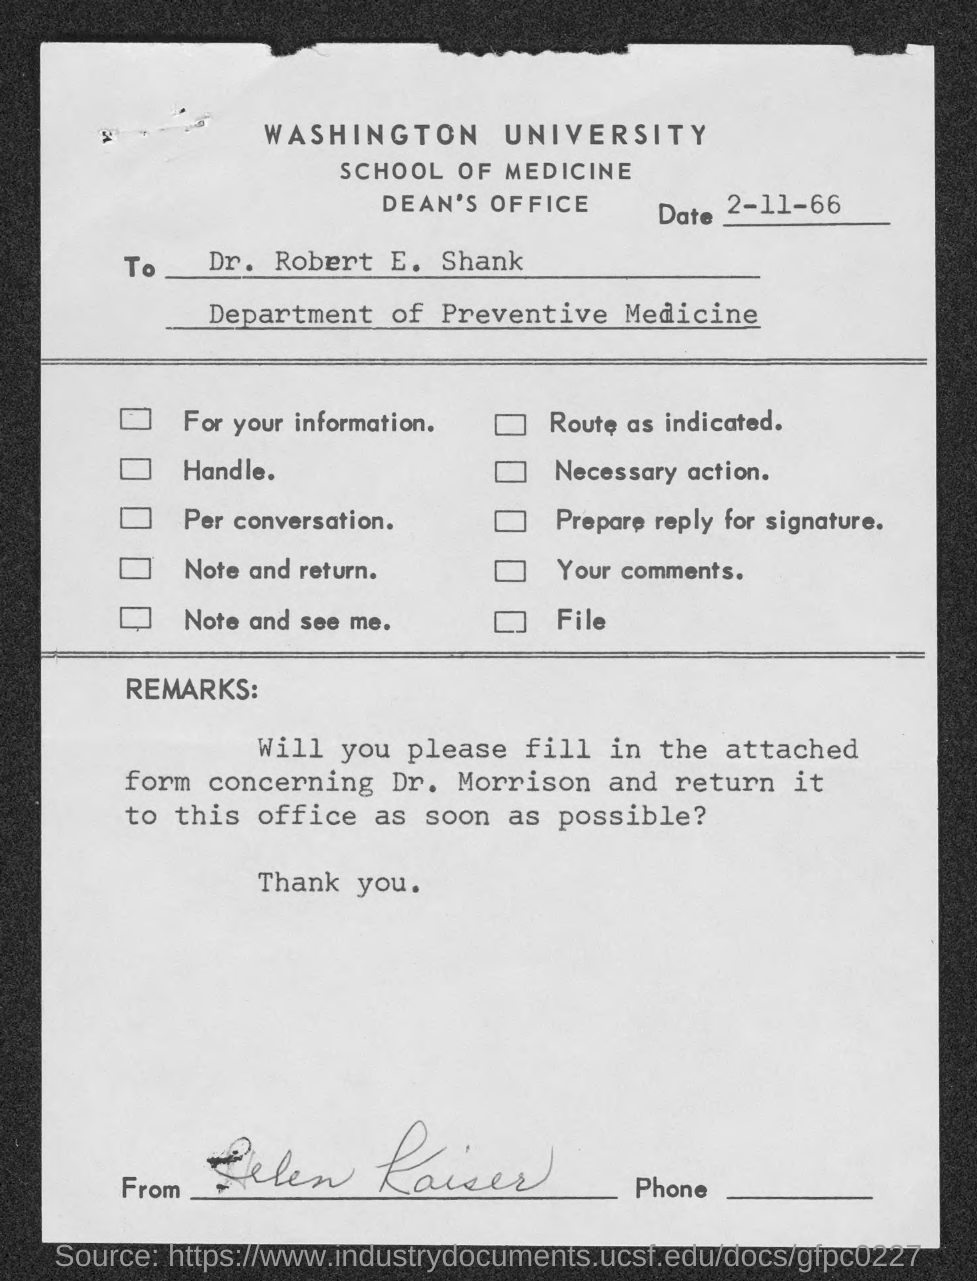What is written in the top of the document ?
Your answer should be compact. Washington University. When is the Memorandum dated on ?
Your response must be concise. 2-11-66. Who is the memorandum addressed to ?
Your answer should be compact. Dr. Robert E. Shank. 